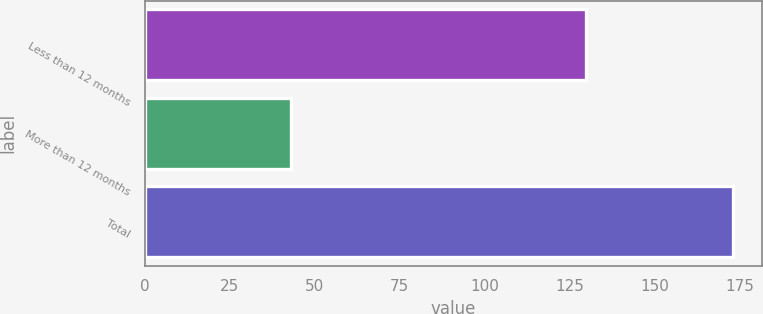<chart> <loc_0><loc_0><loc_500><loc_500><bar_chart><fcel>Less than 12 months<fcel>More than 12 months<fcel>Total<nl><fcel>130<fcel>43<fcel>173<nl></chart> 